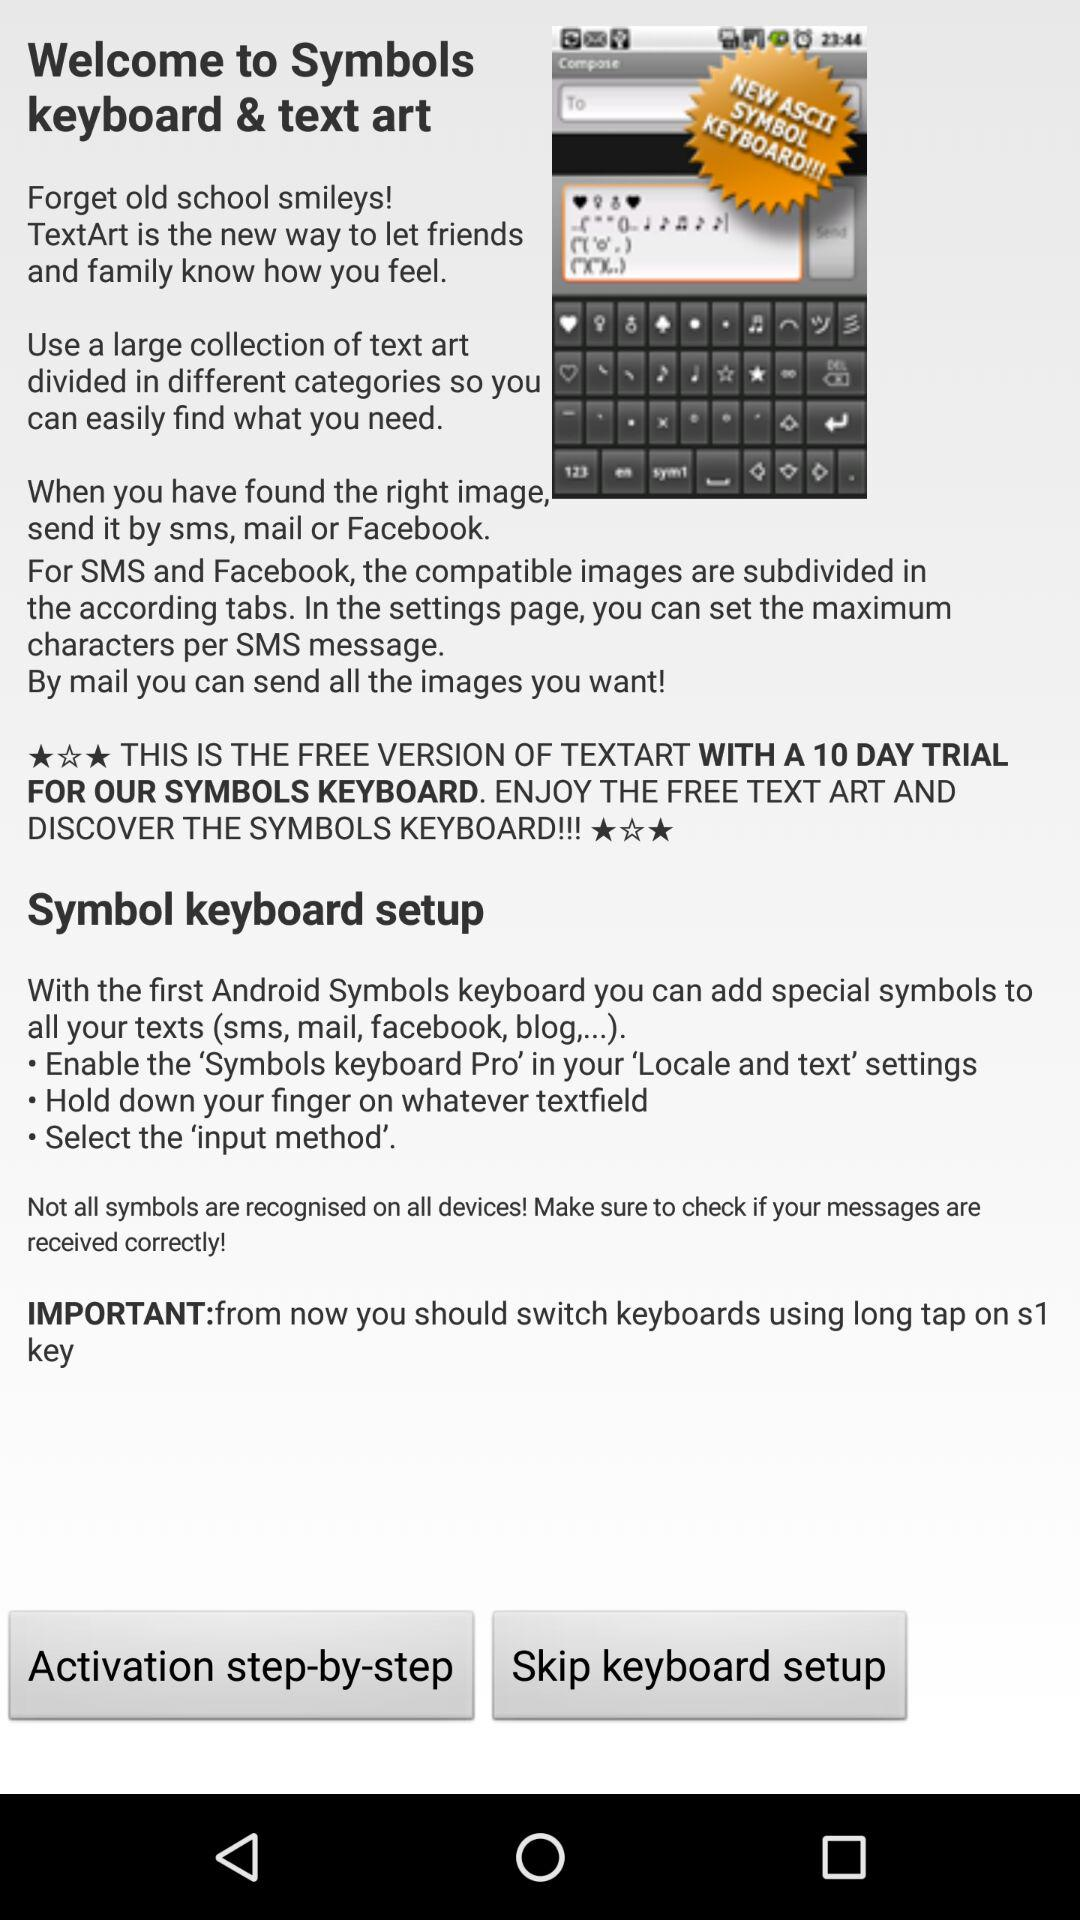What is the name of the application? The name of the application is "Symbols keyboard & text art". 